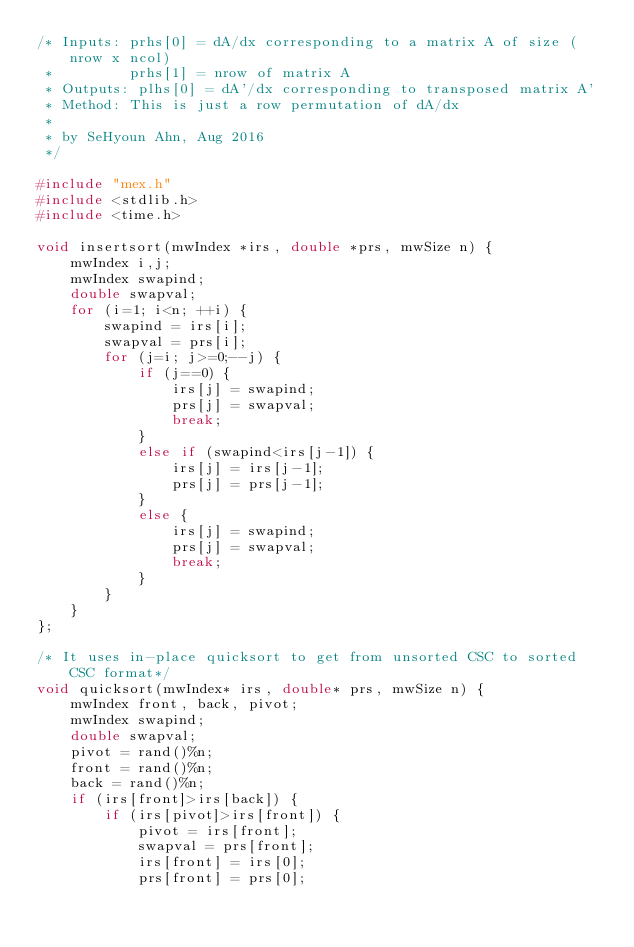Convert code to text. <code><loc_0><loc_0><loc_500><loc_500><_C_>/* Inputs: prhs[0] = dA/dx corresponding to a matrix A of size (nrow x ncol)
 *         prhs[1] = nrow of matrix A
 * Outputs: plhs[0] = dA'/dx corresponding to transposed matrix A'
 * Method: This is just a row permutation of dA/dx
 *
 * by SeHyoun Ahn, Aug 2016
 */

#include "mex.h"
#include <stdlib.h>
#include <time.h>

void insertsort(mwIndex *irs, double *prs, mwSize n) {
    mwIndex i,j;
    mwIndex swapind;
    double swapval;
    for (i=1; i<n; ++i) {
        swapind = irs[i];
        swapval = prs[i];
        for (j=i; j>=0;--j) {
            if (j==0) {
                irs[j] = swapind;
                prs[j] = swapval;
                break;
            }
            else if (swapind<irs[j-1]) {
                irs[j] = irs[j-1];
                prs[j] = prs[j-1];
            }
            else {
                irs[j] = swapind;
                prs[j] = swapval;
                break;
            }
        }
    }
};

/* It uses in-place quicksort to get from unsorted CSC to sorted CSC format*/
void quicksort(mwIndex* irs, double* prs, mwSize n) {
    mwIndex front, back, pivot;
    mwIndex swapind;
    double swapval;
    pivot = rand()%n;
    front = rand()%n;
    back = rand()%n;
    if (irs[front]>irs[back]) {
        if (irs[pivot]>irs[front]) {
            pivot = irs[front];
            swapval = prs[front];
            irs[front] = irs[0];
            prs[front] = prs[0];</code> 